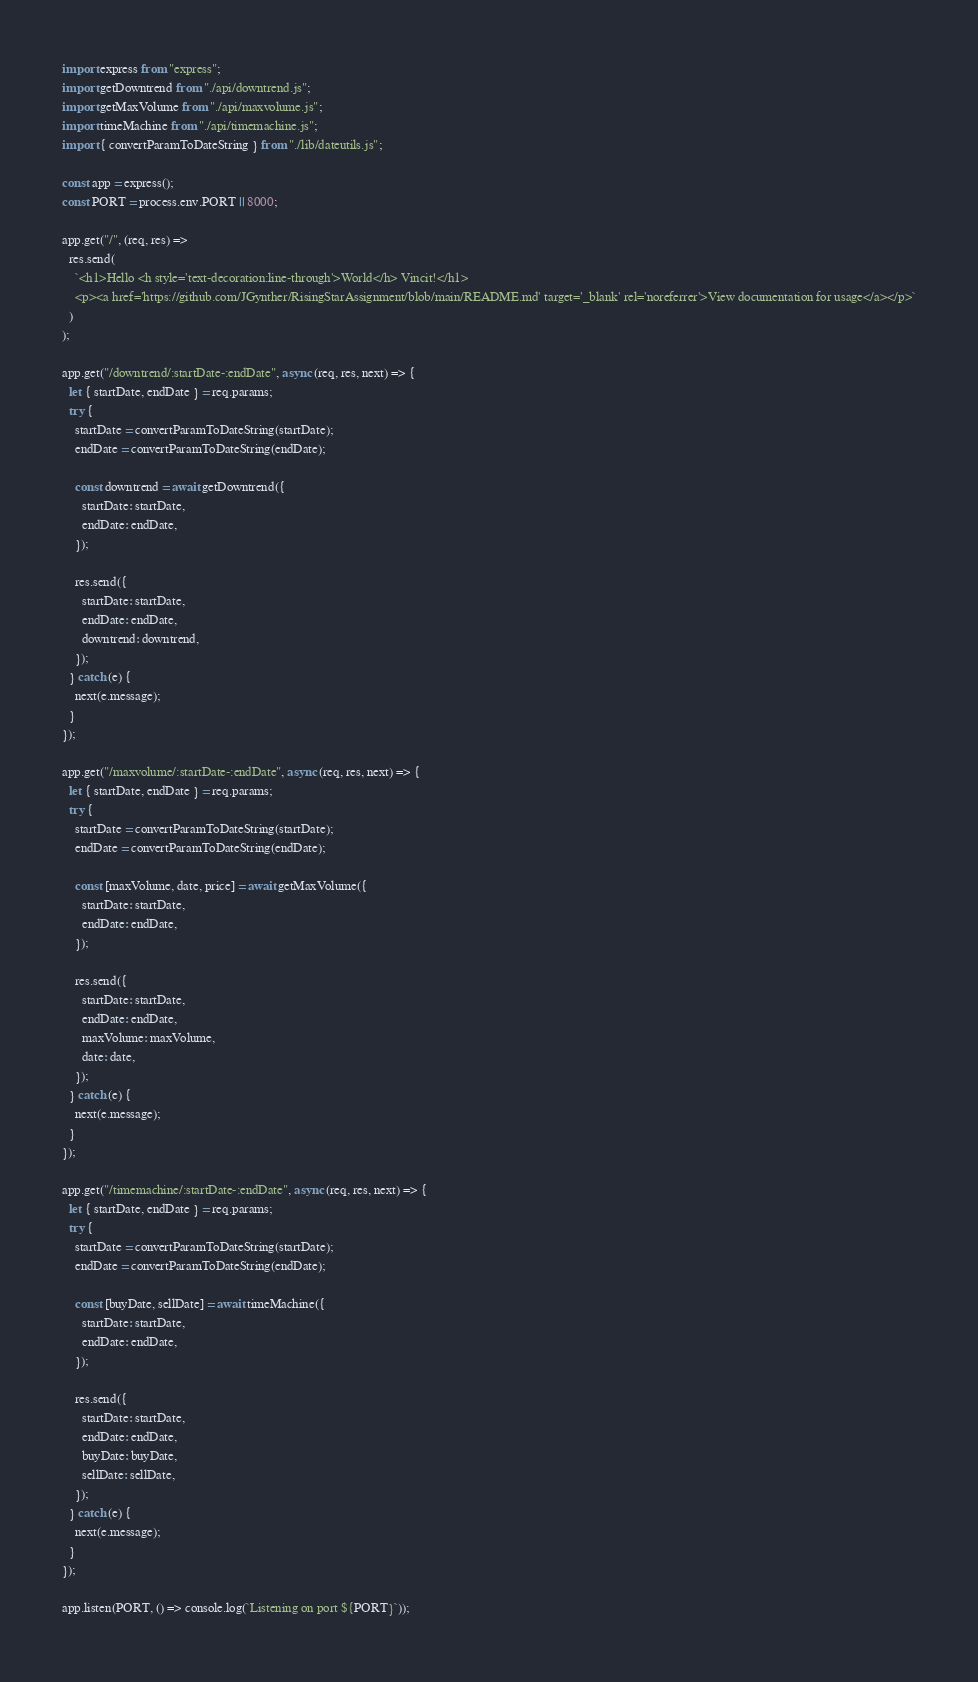<code> <loc_0><loc_0><loc_500><loc_500><_JavaScript_>import express from "express";
import getDowntrend from "./api/downtrend.js";
import getMaxVolume from "./api/maxvolume.js";
import timeMachine from "./api/timemachine.js";
import { convertParamToDateString } from "./lib/dateutils.js";

const app = express();
const PORT = process.env.PORT || 8000;

app.get("/", (req, res) =>
  res.send(
    `<h1>Hello <h style='text-decoration:line-through'>World</h> Vincit!</h1>
    <p><a href='https://github.com/JGynther/RisingStarAssignment/blob/main/README.md' target='_blank' rel='noreferrer'>View documentation for usage</a></p>`
  )
);

app.get("/downtrend/:startDate-:endDate", async (req, res, next) => {
  let { startDate, endDate } = req.params;
  try {
    startDate = convertParamToDateString(startDate);
    endDate = convertParamToDateString(endDate);

    const downtrend = await getDowntrend({
      startDate: startDate,
      endDate: endDate,
    });

    res.send({
      startDate: startDate,
      endDate: endDate,
      downtrend: downtrend,
    });
  } catch (e) {
    next(e.message);
  }
});

app.get("/maxvolume/:startDate-:endDate", async (req, res, next) => {
  let { startDate, endDate } = req.params;
  try {
    startDate = convertParamToDateString(startDate);
    endDate = convertParamToDateString(endDate);

    const [maxVolume, date, price] = await getMaxVolume({
      startDate: startDate,
      endDate: endDate,
    });

    res.send({
      startDate: startDate,
      endDate: endDate,
      maxVolume: maxVolume,
      date: date,
    });
  } catch (e) {
    next(e.message);
  }
});

app.get("/timemachine/:startDate-:endDate", async (req, res, next) => {
  let { startDate, endDate } = req.params;
  try {
    startDate = convertParamToDateString(startDate);
    endDate = convertParamToDateString(endDate);

    const [buyDate, sellDate] = await timeMachine({
      startDate: startDate,
      endDate: endDate,
    });

    res.send({
      startDate: startDate,
      endDate: endDate,
      buyDate: buyDate,
      sellDate: sellDate,
    });
  } catch (e) {
    next(e.message);
  }
});

app.listen(PORT, () => console.log(`Listening on port ${PORT}`));
</code> 